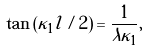<formula> <loc_0><loc_0><loc_500><loc_500>\tan \left ( \kappa _ { 1 } l / 2 \right ) = \frac { 1 } { \lambda \kappa _ { 1 } } ,</formula> 